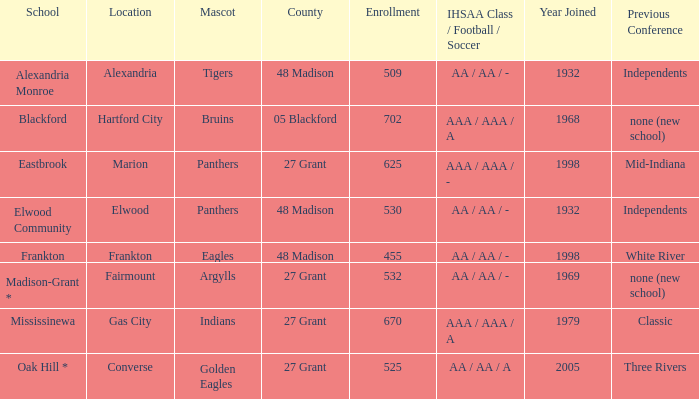What is the previous conference when the location is converse? Three Rivers. 